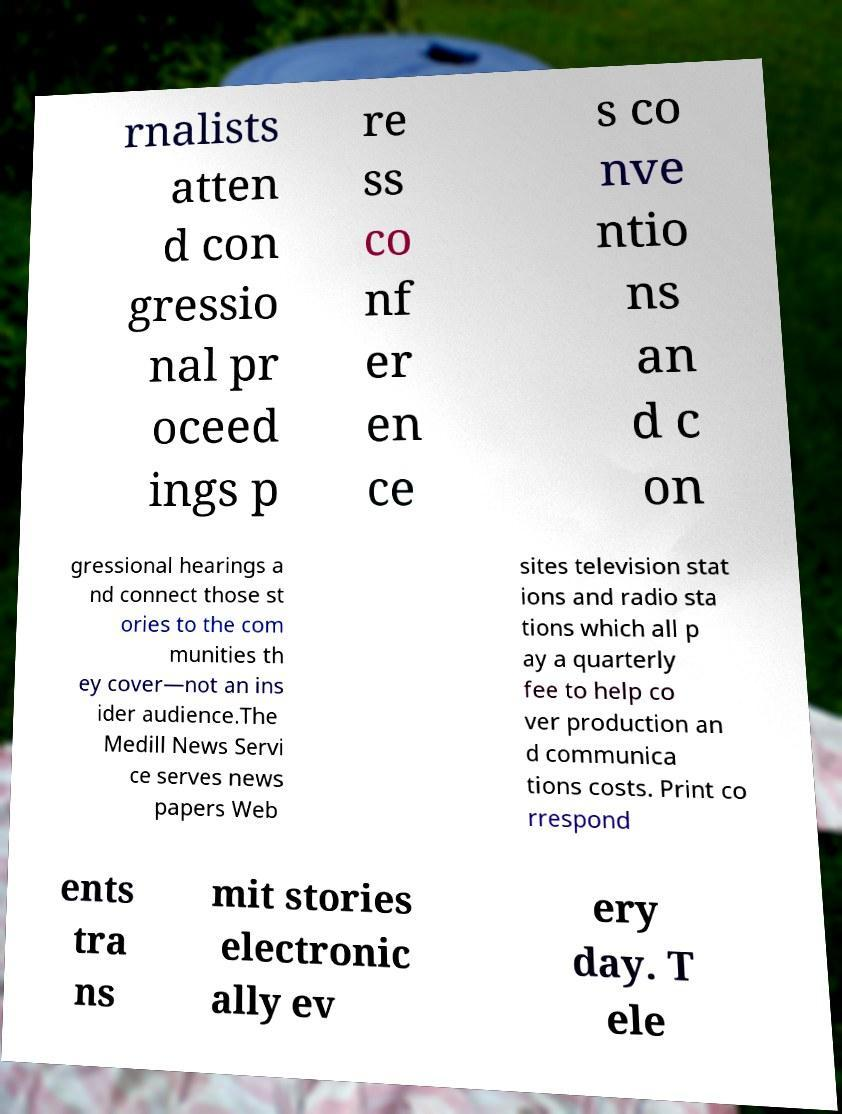Could you assist in decoding the text presented in this image and type it out clearly? rnalists atten d con gressio nal pr oceed ings p re ss co nf er en ce s co nve ntio ns an d c on gressional hearings a nd connect those st ories to the com munities th ey cover—not an ins ider audience.The Medill News Servi ce serves news papers Web sites television stat ions and radio sta tions which all p ay a quarterly fee to help co ver production an d communica tions costs. Print co rrespond ents tra ns mit stories electronic ally ev ery day. T ele 